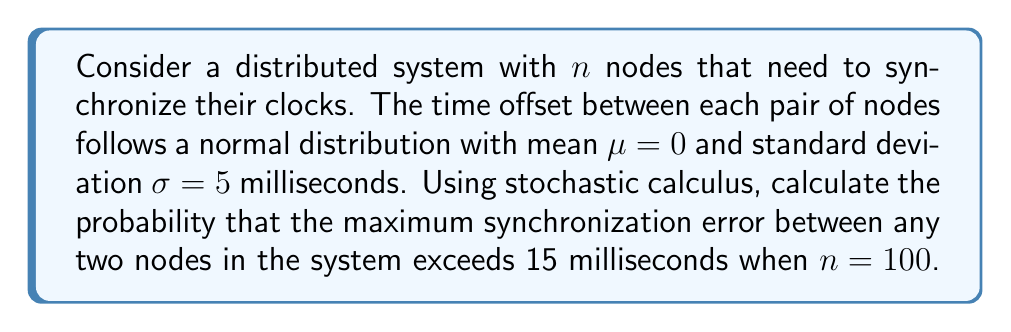Give your solution to this math problem. Let's approach this step-by-step:

1) First, we need to understand that the maximum synchronization error is the maximum difference between any two nodes' clock offsets.

2) For any pair of nodes, their time offset difference follows a normal distribution with:
   $\mu_{diff} = 0$ (since $\mu = 0$ for each offset)
   $\sigma_{diff} = \sqrt{2}\sigma$ (since we're dealing with the difference of two independent normal distributions)

3) So, $\sigma_{diff} = \sqrt{2} * 5 = 5\sqrt{2}$ milliseconds

4) The probability that the difference between any two nodes exceeds 15 ms is:

   $P(|X| > 15) = 2 * (1 - \Phi(\frac{15}{5\sqrt{2}}))$

   where $\Phi$ is the cumulative distribution function of the standard normal distribution.

5) $\frac{15}{5\sqrt{2}} \approx 2.12132$

6) $\Phi(2.12132) \approx 0.98303$

7) So, $P(|X| > 15) = 2 * (1 - 0.98303) \approx 0.03394$

8) Now, we need to calculate the probability that at least one pair of nodes has a difference exceeding 15 ms. This is equivalent to 1 minus the probability that no pair exceeds 15 ms.

9) The number of possible pairs in a system with 100 nodes is $\binom{100}{2} = 4950$

10) The probability that no pair exceeds 15 ms is:

    $(1 - 0.03394)^{4950} \approx 0.00000616$

11) Therefore, the probability that at least one pair (i.e., the maximum error) exceeds 15 ms is:

    $1 - 0.00000616 \approx 0.99999384$
Answer: $0.99999384$ 